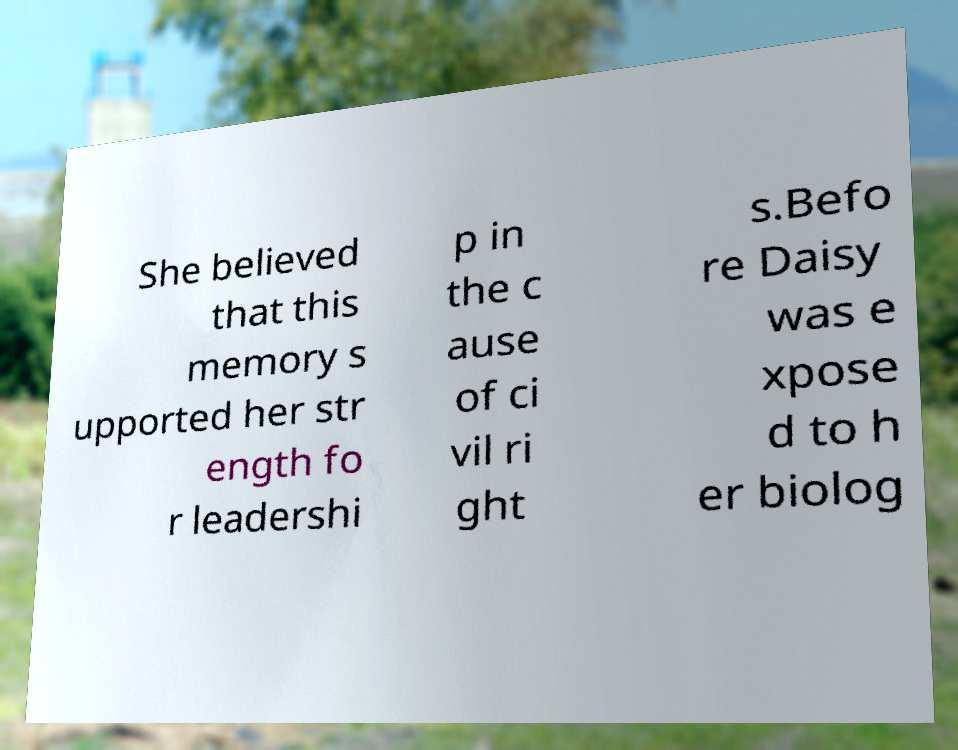I need the written content from this picture converted into text. Can you do that? She believed that this memory s upported her str ength fo r leadershi p in the c ause of ci vil ri ght s.Befo re Daisy was e xpose d to h er biolog 